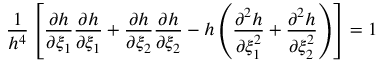<formula> <loc_0><loc_0><loc_500><loc_500>\frac { 1 } { h ^ { 4 } } \left [ \frac { \partial h } { \partial \xi _ { 1 } } \frac { \partial h } { \partial \xi _ { 1 } } + \frac { \partial h } { \partial \xi _ { 2 } } \frac { \partial h } { \partial \xi _ { 2 } } - h \left ( \frac { \partial ^ { 2 } h } { \partial \xi _ { 1 } ^ { 2 } } + \frac { \partial ^ { 2 } h } { \partial \xi _ { 2 } ^ { 2 } } \right ) \right ] = 1</formula> 